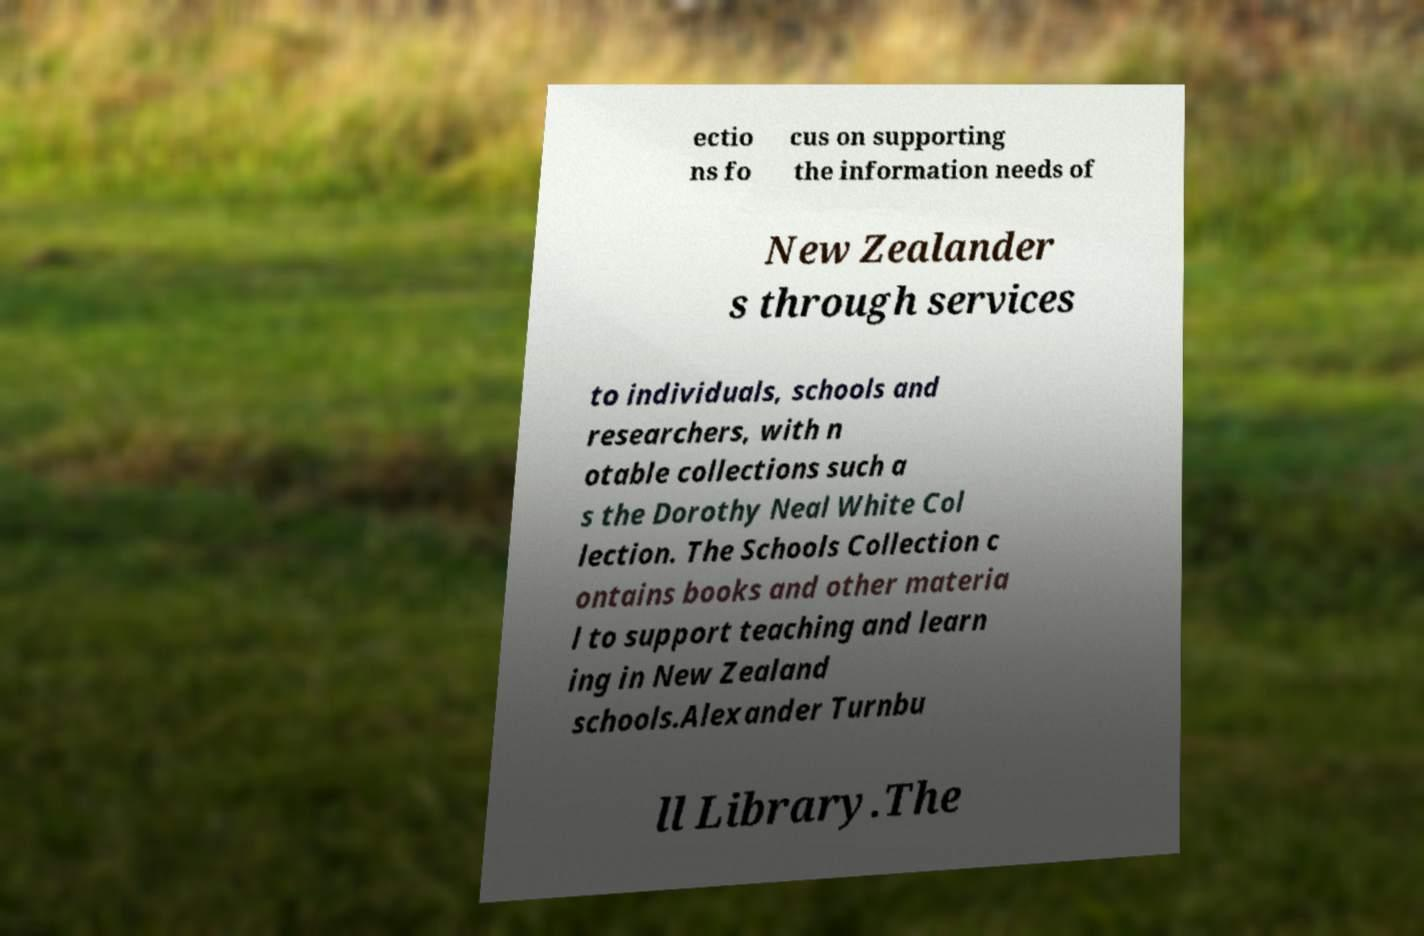There's text embedded in this image that I need extracted. Can you transcribe it verbatim? ectio ns fo cus on supporting the information needs of New Zealander s through services to individuals, schools and researchers, with n otable collections such a s the Dorothy Neal White Col lection. The Schools Collection c ontains books and other materia l to support teaching and learn ing in New Zealand schools.Alexander Turnbu ll Library.The 